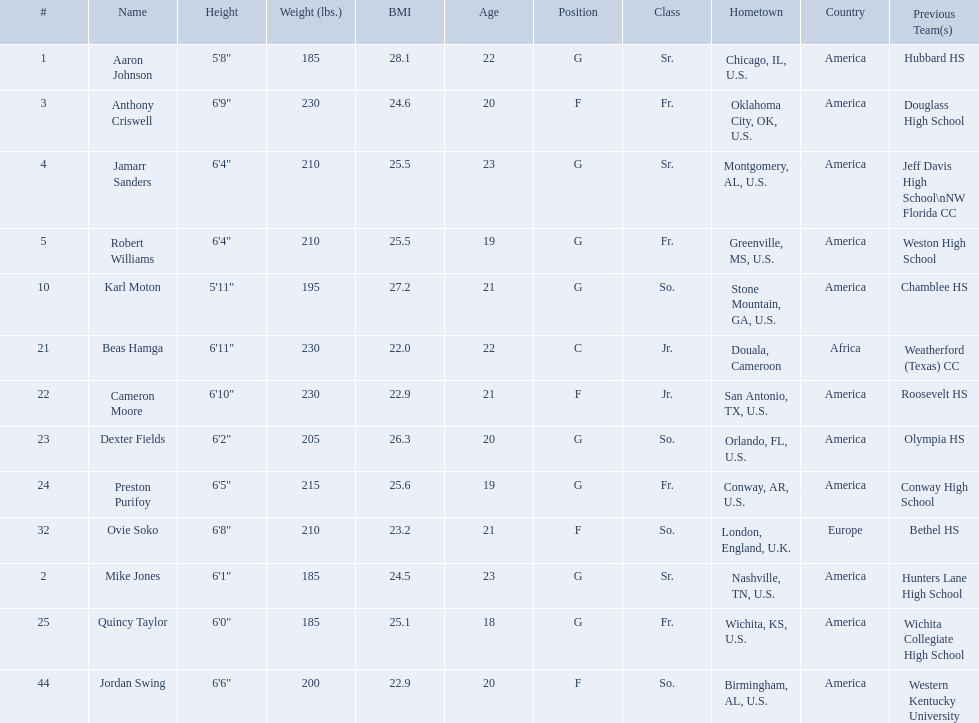Other than soko, who are the players? Aaron Johnson, Anthony Criswell, Jamarr Sanders, Robert Williams, Karl Moton, Beas Hamga, Cameron Moore, Dexter Fields, Preston Purifoy, Mike Jones, Quincy Taylor, Jordan Swing. Of those players, who is a player that is not from the us? Beas Hamga. 